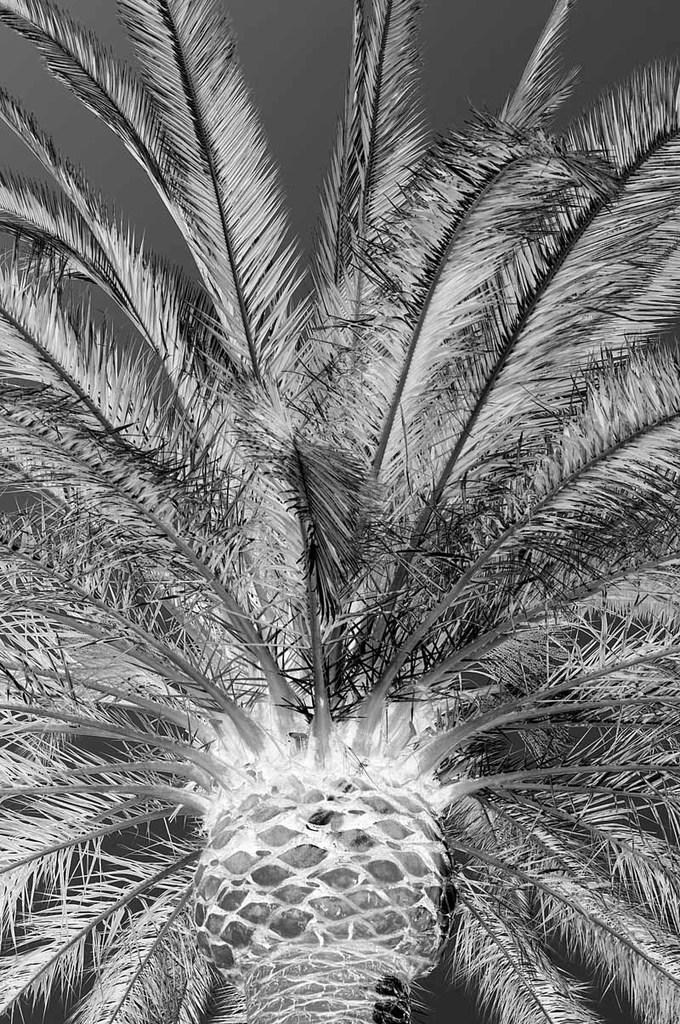What is the color scheme of the image? The image is black and white. What natural element can be seen in the image? There is a tree in the image. What are the leaves on the tree like? The tree has leaves. What is the main part of the tree that supports its structure? The tree has a trunk. How many icicles are hanging from the tree in the image? There are no icicles present in the image, as it is a black and white image of a tree with leaves and a trunk. What verse is being recited by the tree in the image? There is no verse being recited by the tree in the image, as trees do not have the ability to recite verses. 